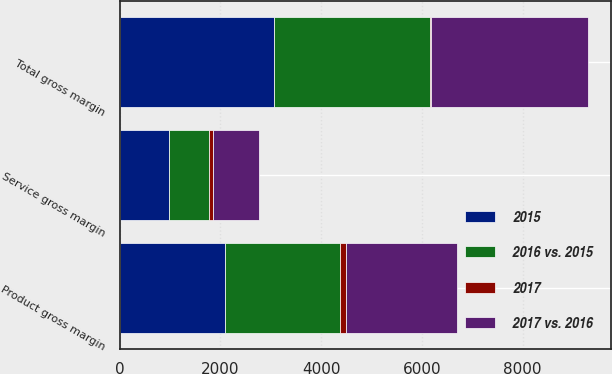Convert chart to OTSL. <chart><loc_0><loc_0><loc_500><loc_500><stacked_bar_chart><ecel><fcel>Product gross margin<fcel>Service gross margin<fcel>Total gross margin<nl><fcel>2015<fcel>2085.3<fcel>986.8<fcel>3072.1<nl><fcel>2017 vs. 2016<fcel>2202.7<fcel>901.8<fcel>3104.5<nl><fcel>2016 vs. 2015<fcel>2293.5<fcel>785.1<fcel>3078.6<nl><fcel>2017<fcel>117.4<fcel>85<fcel>32.4<nl></chart> 